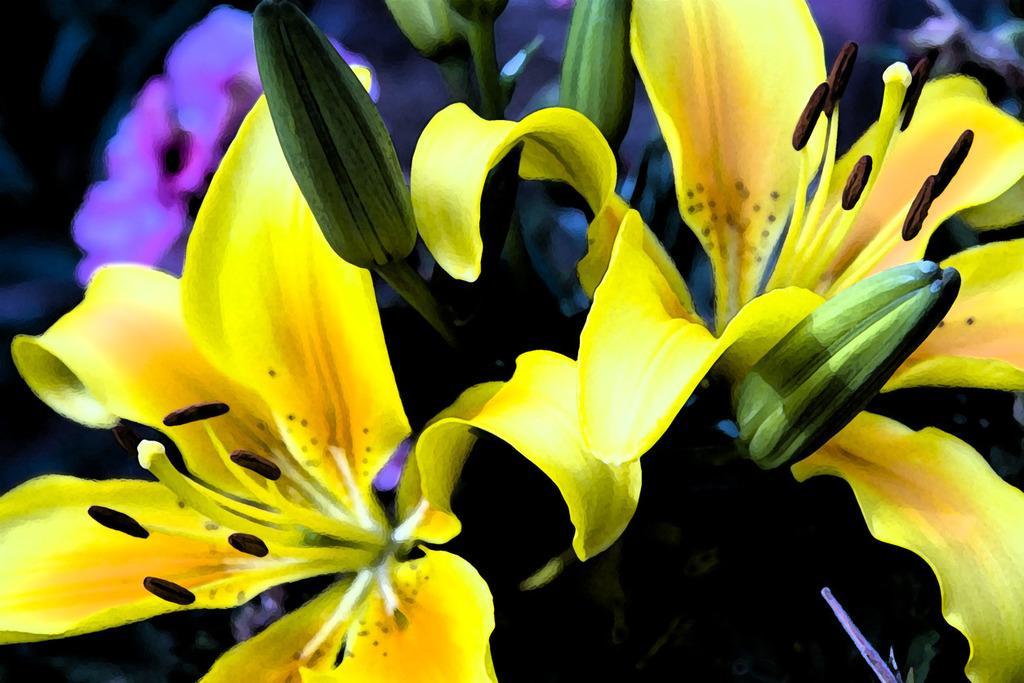Please provide a concise description of this image. This is the picture of flowers. There are yellow flowers and green buds in the foreground. 